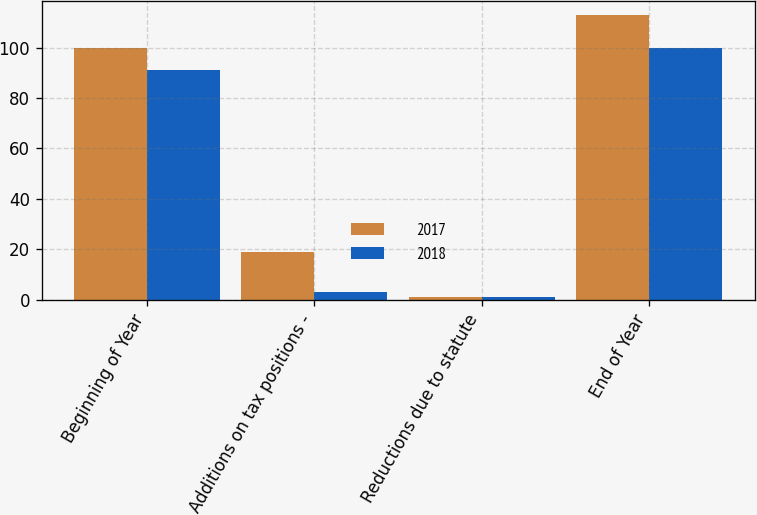Convert chart to OTSL. <chart><loc_0><loc_0><loc_500><loc_500><stacked_bar_chart><ecel><fcel>Beginning of Year<fcel>Additions on tax positions -<fcel>Reductions due to statute<fcel>End of Year<nl><fcel>2017<fcel>100<fcel>19<fcel>1<fcel>113<nl><fcel>2018<fcel>91<fcel>3<fcel>1<fcel>100<nl></chart> 